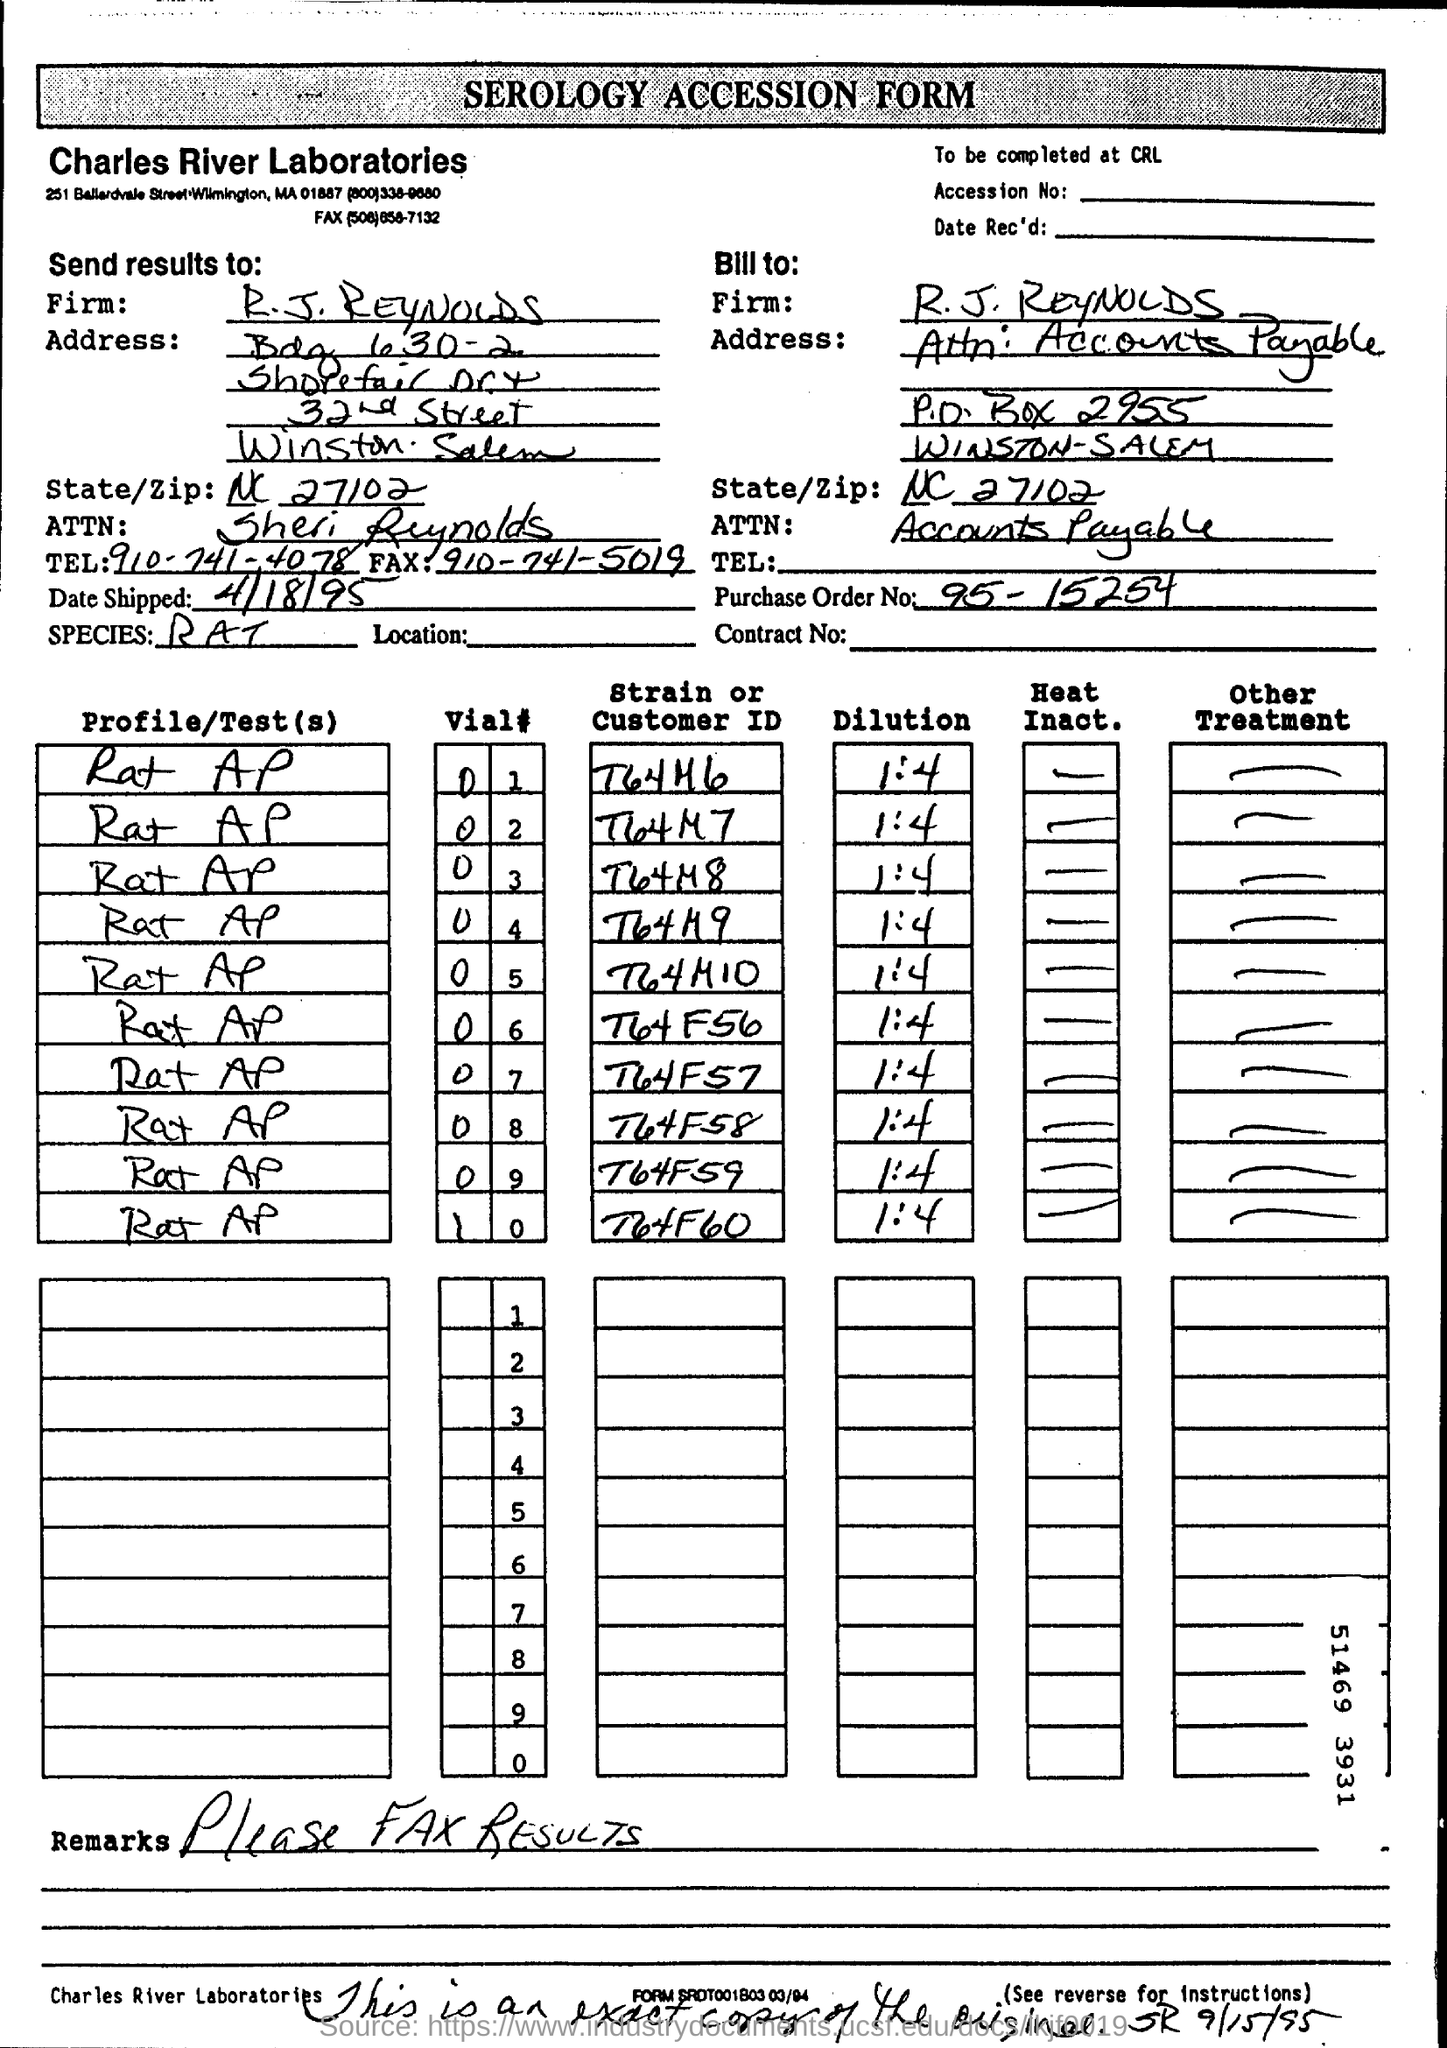Draw attention to some important aspects in this diagram. What is the name of the form? It is a SEROLOGY ACCESSION FORM. The Purchase Order No given is 95-15254. The name of the laboratories in the form is Charles River Laboratories. 